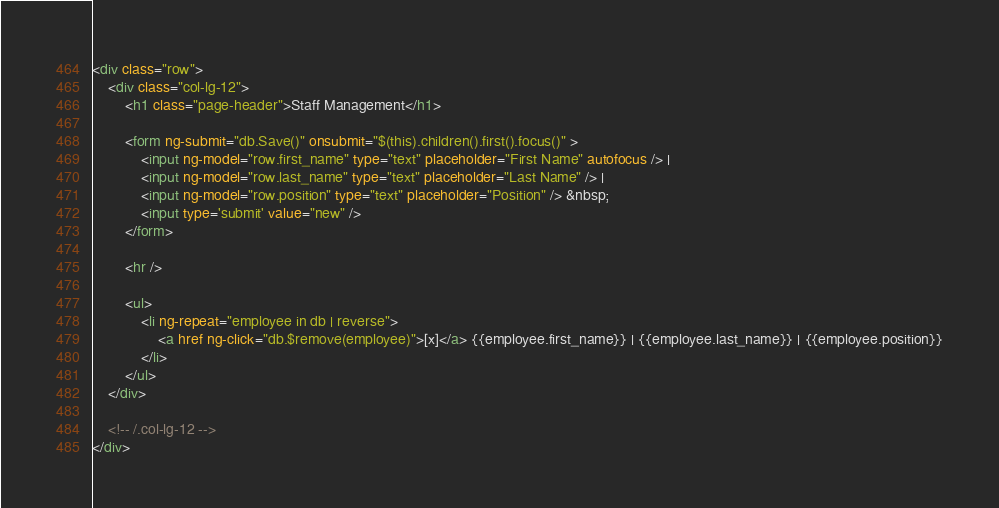Convert code to text. <code><loc_0><loc_0><loc_500><loc_500><_HTML_><div class="row">
	<div class="col-lg-12">
		<h1 class="page-header">Staff Management</h1>
		
		<form ng-submit="db.Save()" onsubmit="$(this).children().first().focus()" >
			<input ng-model="row.first_name" type="text" placeholder="First Name" autofocus /> | 
			<input ng-model="row.last_name" type="text" placeholder="Last Name" /> |
			<input ng-model="row.position" type="text" placeholder="Position" /> &nbsp;
			<input type='submit' value="new" />
		</form>
		
		<hr />
		
		<ul>
			<li ng-repeat="employee in db | reverse">
				<a href ng-click="db.$remove(employee)">[x]</a> {{employee.first_name}} | {{employee.last_name}} | {{employee.position}}
			</li>
		</ul>
	</div>	
	
	<!-- /.col-lg-12 -->
</div></code> 